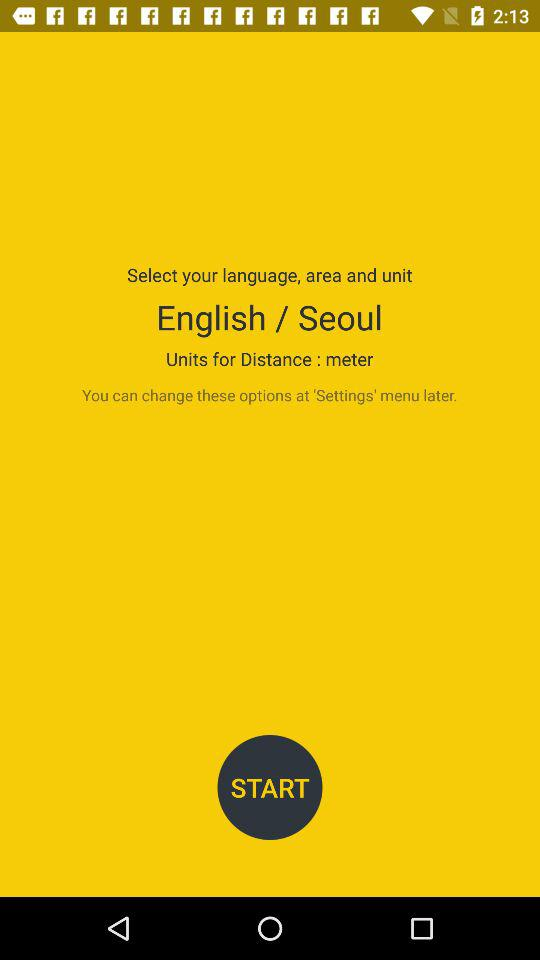Which language is selected? The selected language is English. 